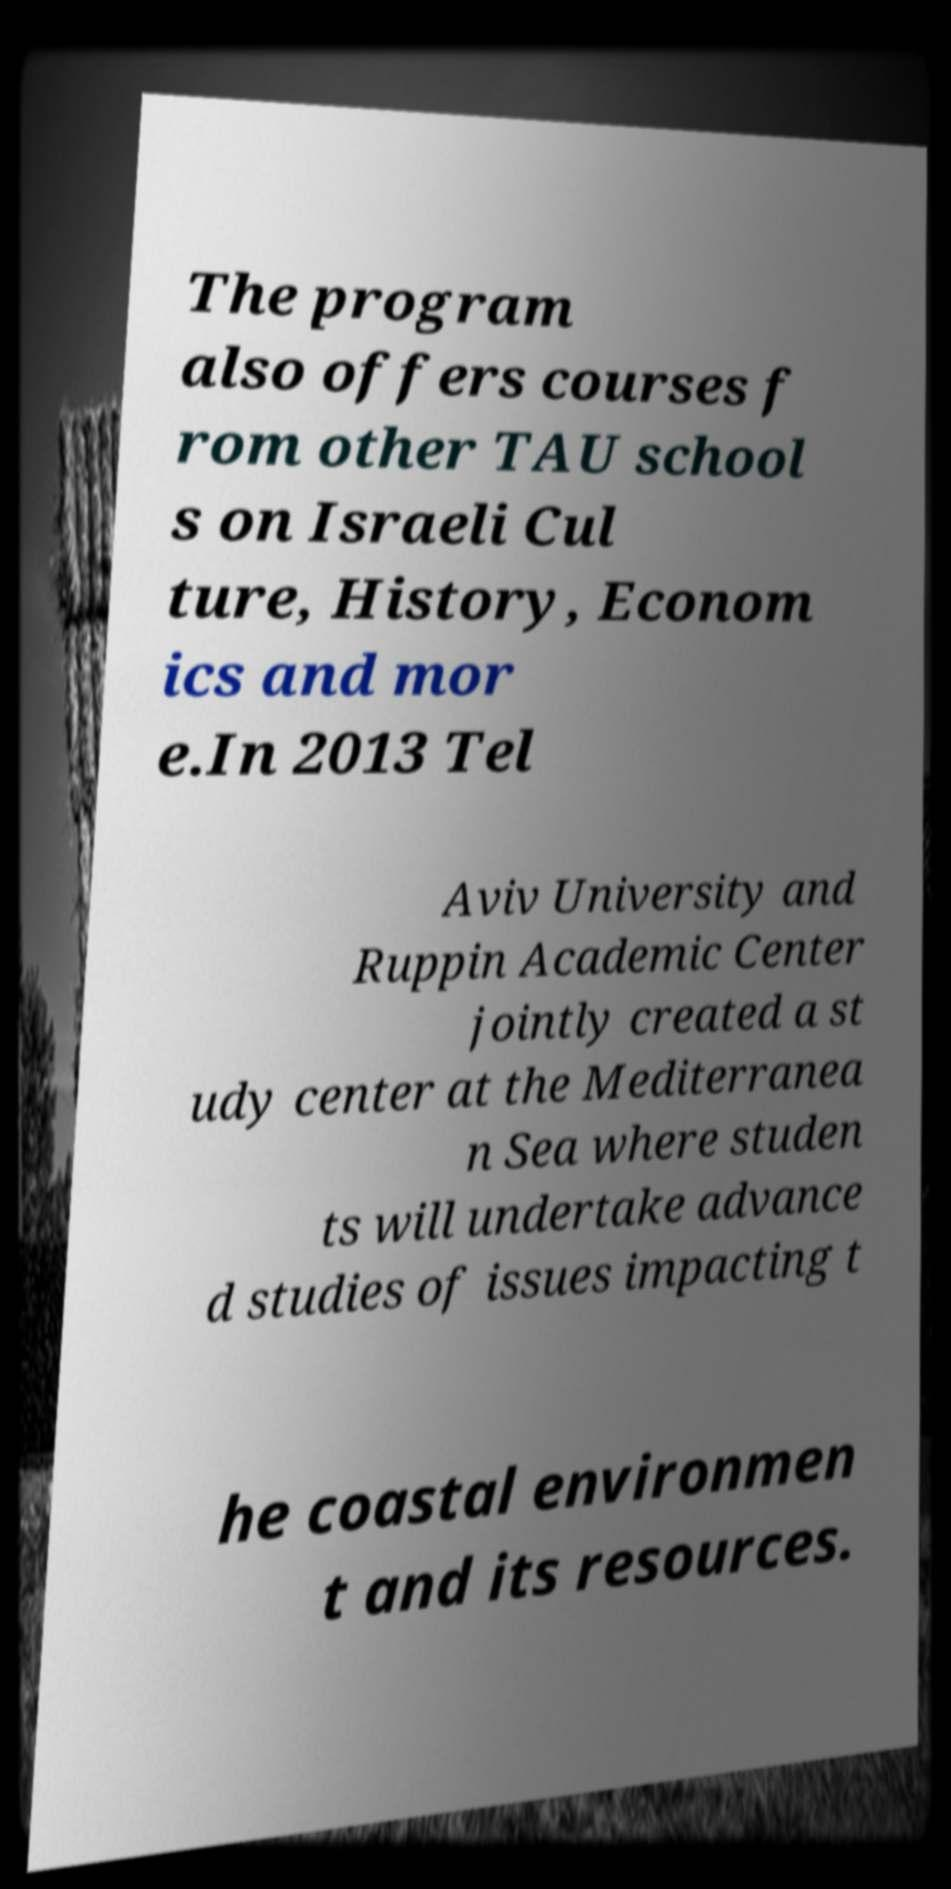Please read and relay the text visible in this image. What does it say? The program also offers courses f rom other TAU school s on Israeli Cul ture, History, Econom ics and mor e.In 2013 Tel Aviv University and Ruppin Academic Center jointly created a st udy center at the Mediterranea n Sea where studen ts will undertake advance d studies of issues impacting t he coastal environmen t and its resources. 